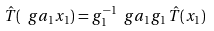Convert formula to latex. <formula><loc_0><loc_0><loc_500><loc_500>\hat { T } ( \ g a _ { 1 } x _ { 1 } ) = g _ { 1 } ^ { - 1 } \ g a _ { 1 } g _ { 1 } \, \hat { T } ( x _ { 1 } )</formula> 